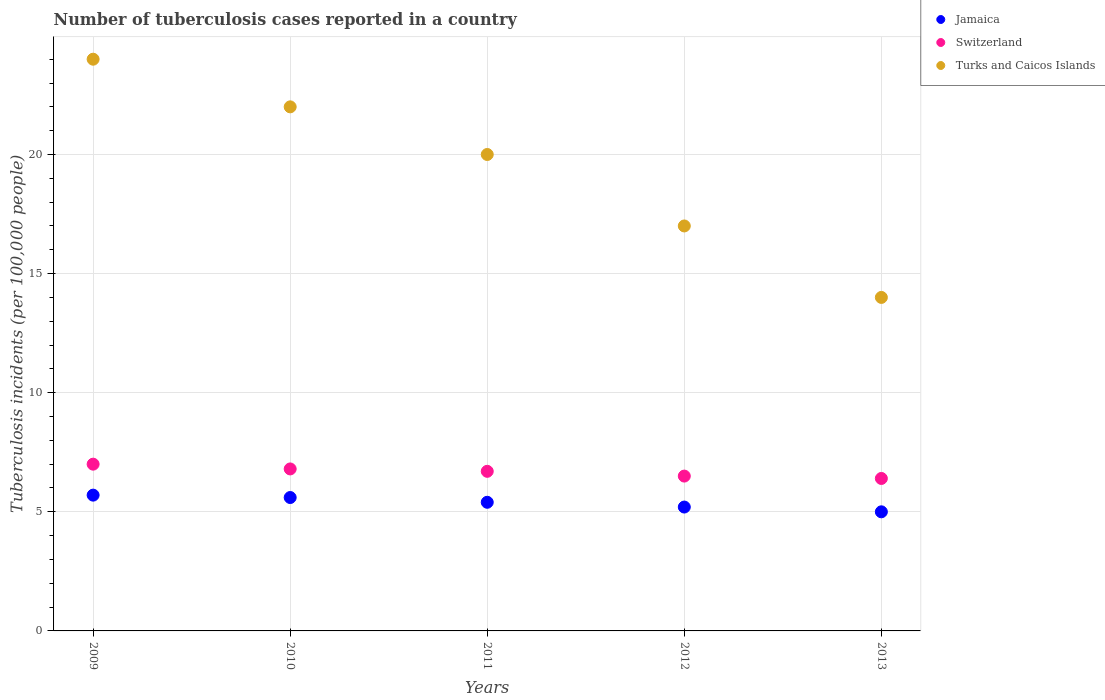What is the number of tuberculosis cases reported in in Turks and Caicos Islands in 2011?
Your answer should be compact. 20. Across all years, what is the maximum number of tuberculosis cases reported in in Turks and Caicos Islands?
Provide a short and direct response. 24. Across all years, what is the minimum number of tuberculosis cases reported in in Turks and Caicos Islands?
Keep it short and to the point. 14. In which year was the number of tuberculosis cases reported in in Jamaica maximum?
Ensure brevity in your answer.  2009. In which year was the number of tuberculosis cases reported in in Jamaica minimum?
Your answer should be compact. 2013. What is the total number of tuberculosis cases reported in in Turks and Caicos Islands in the graph?
Keep it short and to the point. 97. What is the difference between the number of tuberculosis cases reported in in Switzerland in 2012 and that in 2013?
Provide a succinct answer. 0.1. What is the average number of tuberculosis cases reported in in Switzerland per year?
Provide a succinct answer. 6.68. In the year 2013, what is the difference between the number of tuberculosis cases reported in in Jamaica and number of tuberculosis cases reported in in Turks and Caicos Islands?
Ensure brevity in your answer.  -9. In how many years, is the number of tuberculosis cases reported in in Turks and Caicos Islands greater than 15?
Make the answer very short. 4. Is the number of tuberculosis cases reported in in Switzerland in 2010 less than that in 2013?
Keep it short and to the point. No. Is the difference between the number of tuberculosis cases reported in in Jamaica in 2009 and 2011 greater than the difference between the number of tuberculosis cases reported in in Turks and Caicos Islands in 2009 and 2011?
Ensure brevity in your answer.  No. What is the difference between the highest and the second highest number of tuberculosis cases reported in in Switzerland?
Provide a succinct answer. 0.2. What is the difference between the highest and the lowest number of tuberculosis cases reported in in Jamaica?
Your answer should be compact. 0.7. In how many years, is the number of tuberculosis cases reported in in Switzerland greater than the average number of tuberculosis cases reported in in Switzerland taken over all years?
Provide a short and direct response. 3. Is the number of tuberculosis cases reported in in Switzerland strictly greater than the number of tuberculosis cases reported in in Turks and Caicos Islands over the years?
Your response must be concise. No. Is the number of tuberculosis cases reported in in Turks and Caicos Islands strictly less than the number of tuberculosis cases reported in in Switzerland over the years?
Offer a very short reply. No. How many dotlines are there?
Make the answer very short. 3. What is the difference between two consecutive major ticks on the Y-axis?
Offer a very short reply. 5. Are the values on the major ticks of Y-axis written in scientific E-notation?
Give a very brief answer. No. Does the graph contain any zero values?
Provide a succinct answer. No. How many legend labels are there?
Provide a succinct answer. 3. What is the title of the graph?
Offer a very short reply. Number of tuberculosis cases reported in a country. Does "Armenia" appear as one of the legend labels in the graph?
Your answer should be compact. No. What is the label or title of the Y-axis?
Offer a very short reply. Tuberculosis incidents (per 100,0 people). What is the Tuberculosis incidents (per 100,000 people) of Switzerland in 2009?
Offer a very short reply. 7. What is the Tuberculosis incidents (per 100,000 people) of Turks and Caicos Islands in 2009?
Offer a terse response. 24. What is the Tuberculosis incidents (per 100,000 people) in Turks and Caicos Islands in 2010?
Your answer should be very brief. 22. What is the Tuberculosis incidents (per 100,000 people) of Jamaica in 2011?
Your answer should be very brief. 5.4. What is the Tuberculosis incidents (per 100,000 people) of Switzerland in 2011?
Offer a very short reply. 6.7. What is the Tuberculosis incidents (per 100,000 people) of Turks and Caicos Islands in 2011?
Ensure brevity in your answer.  20. What is the Tuberculosis incidents (per 100,000 people) of Switzerland in 2012?
Your response must be concise. 6.5. What is the Tuberculosis incidents (per 100,000 people) in Jamaica in 2013?
Your answer should be very brief. 5. Across all years, what is the maximum Tuberculosis incidents (per 100,000 people) in Switzerland?
Make the answer very short. 7. Across all years, what is the maximum Tuberculosis incidents (per 100,000 people) of Turks and Caicos Islands?
Offer a very short reply. 24. What is the total Tuberculosis incidents (per 100,000 people) of Jamaica in the graph?
Your answer should be very brief. 26.9. What is the total Tuberculosis incidents (per 100,000 people) in Switzerland in the graph?
Ensure brevity in your answer.  33.4. What is the total Tuberculosis incidents (per 100,000 people) of Turks and Caicos Islands in the graph?
Your answer should be very brief. 97. What is the difference between the Tuberculosis incidents (per 100,000 people) in Jamaica in 2009 and that in 2010?
Give a very brief answer. 0.1. What is the difference between the Tuberculosis incidents (per 100,000 people) of Jamaica in 2009 and that in 2011?
Provide a succinct answer. 0.3. What is the difference between the Tuberculosis incidents (per 100,000 people) of Switzerland in 2009 and that in 2011?
Keep it short and to the point. 0.3. What is the difference between the Tuberculosis incidents (per 100,000 people) in Switzerland in 2009 and that in 2012?
Offer a terse response. 0.5. What is the difference between the Tuberculosis incidents (per 100,000 people) of Turks and Caicos Islands in 2009 and that in 2012?
Your answer should be very brief. 7. What is the difference between the Tuberculosis incidents (per 100,000 people) in Switzerland in 2009 and that in 2013?
Offer a very short reply. 0.6. What is the difference between the Tuberculosis incidents (per 100,000 people) of Switzerland in 2010 and that in 2011?
Provide a succinct answer. 0.1. What is the difference between the Tuberculosis incidents (per 100,000 people) of Turks and Caicos Islands in 2010 and that in 2011?
Provide a succinct answer. 2. What is the difference between the Tuberculosis incidents (per 100,000 people) in Jamaica in 2010 and that in 2012?
Provide a short and direct response. 0.4. What is the difference between the Tuberculosis incidents (per 100,000 people) of Switzerland in 2010 and that in 2013?
Your answer should be very brief. 0.4. What is the difference between the Tuberculosis incidents (per 100,000 people) in Switzerland in 2011 and that in 2012?
Give a very brief answer. 0.2. What is the difference between the Tuberculosis incidents (per 100,000 people) of Switzerland in 2011 and that in 2013?
Your answer should be compact. 0.3. What is the difference between the Tuberculosis incidents (per 100,000 people) in Turks and Caicos Islands in 2011 and that in 2013?
Offer a very short reply. 6. What is the difference between the Tuberculosis incidents (per 100,000 people) in Jamaica in 2012 and that in 2013?
Make the answer very short. 0.2. What is the difference between the Tuberculosis incidents (per 100,000 people) of Turks and Caicos Islands in 2012 and that in 2013?
Offer a terse response. 3. What is the difference between the Tuberculosis incidents (per 100,000 people) in Jamaica in 2009 and the Tuberculosis incidents (per 100,000 people) in Switzerland in 2010?
Your answer should be compact. -1.1. What is the difference between the Tuberculosis incidents (per 100,000 people) of Jamaica in 2009 and the Tuberculosis incidents (per 100,000 people) of Turks and Caicos Islands in 2010?
Your answer should be compact. -16.3. What is the difference between the Tuberculosis incidents (per 100,000 people) in Jamaica in 2009 and the Tuberculosis incidents (per 100,000 people) in Switzerland in 2011?
Offer a terse response. -1. What is the difference between the Tuberculosis incidents (per 100,000 people) in Jamaica in 2009 and the Tuberculosis incidents (per 100,000 people) in Turks and Caicos Islands in 2011?
Your response must be concise. -14.3. What is the difference between the Tuberculosis incidents (per 100,000 people) of Jamaica in 2009 and the Tuberculosis incidents (per 100,000 people) of Turks and Caicos Islands in 2012?
Provide a short and direct response. -11.3. What is the difference between the Tuberculosis incidents (per 100,000 people) of Jamaica in 2009 and the Tuberculosis incidents (per 100,000 people) of Switzerland in 2013?
Offer a terse response. -0.7. What is the difference between the Tuberculosis incidents (per 100,000 people) in Jamaica in 2010 and the Tuberculosis incidents (per 100,000 people) in Turks and Caicos Islands in 2011?
Your answer should be very brief. -14.4. What is the difference between the Tuberculosis incidents (per 100,000 people) of Switzerland in 2010 and the Tuberculosis incidents (per 100,000 people) of Turks and Caicos Islands in 2011?
Offer a terse response. -13.2. What is the difference between the Tuberculosis incidents (per 100,000 people) in Jamaica in 2010 and the Tuberculosis incidents (per 100,000 people) in Turks and Caicos Islands in 2012?
Offer a very short reply. -11.4. What is the difference between the Tuberculosis incidents (per 100,000 people) in Jamaica in 2010 and the Tuberculosis incidents (per 100,000 people) in Switzerland in 2013?
Offer a terse response. -0.8. What is the difference between the Tuberculosis incidents (per 100,000 people) of Jamaica in 2011 and the Tuberculosis incidents (per 100,000 people) of Turks and Caicos Islands in 2012?
Offer a very short reply. -11.6. What is the difference between the Tuberculosis incidents (per 100,000 people) of Switzerland in 2011 and the Tuberculosis incidents (per 100,000 people) of Turks and Caicos Islands in 2012?
Ensure brevity in your answer.  -10.3. What is the difference between the Tuberculosis incidents (per 100,000 people) in Jamaica in 2011 and the Tuberculosis incidents (per 100,000 people) in Turks and Caicos Islands in 2013?
Keep it short and to the point. -8.6. What is the difference between the Tuberculosis incidents (per 100,000 people) of Jamaica in 2012 and the Tuberculosis incidents (per 100,000 people) of Turks and Caicos Islands in 2013?
Provide a succinct answer. -8.8. What is the difference between the Tuberculosis incidents (per 100,000 people) of Switzerland in 2012 and the Tuberculosis incidents (per 100,000 people) of Turks and Caicos Islands in 2013?
Offer a very short reply. -7.5. What is the average Tuberculosis incidents (per 100,000 people) in Jamaica per year?
Give a very brief answer. 5.38. What is the average Tuberculosis incidents (per 100,000 people) in Switzerland per year?
Offer a terse response. 6.68. In the year 2009, what is the difference between the Tuberculosis incidents (per 100,000 people) of Jamaica and Tuberculosis incidents (per 100,000 people) of Switzerland?
Keep it short and to the point. -1.3. In the year 2009, what is the difference between the Tuberculosis incidents (per 100,000 people) of Jamaica and Tuberculosis incidents (per 100,000 people) of Turks and Caicos Islands?
Your answer should be very brief. -18.3. In the year 2009, what is the difference between the Tuberculosis incidents (per 100,000 people) of Switzerland and Tuberculosis incidents (per 100,000 people) of Turks and Caicos Islands?
Offer a very short reply. -17. In the year 2010, what is the difference between the Tuberculosis incidents (per 100,000 people) in Jamaica and Tuberculosis incidents (per 100,000 people) in Turks and Caicos Islands?
Your response must be concise. -16.4. In the year 2010, what is the difference between the Tuberculosis incidents (per 100,000 people) in Switzerland and Tuberculosis incidents (per 100,000 people) in Turks and Caicos Islands?
Offer a terse response. -15.2. In the year 2011, what is the difference between the Tuberculosis incidents (per 100,000 people) of Jamaica and Tuberculosis incidents (per 100,000 people) of Switzerland?
Provide a succinct answer. -1.3. In the year 2011, what is the difference between the Tuberculosis incidents (per 100,000 people) of Jamaica and Tuberculosis incidents (per 100,000 people) of Turks and Caicos Islands?
Keep it short and to the point. -14.6. In the year 2011, what is the difference between the Tuberculosis incidents (per 100,000 people) in Switzerland and Tuberculosis incidents (per 100,000 people) in Turks and Caicos Islands?
Provide a short and direct response. -13.3. In the year 2012, what is the difference between the Tuberculosis incidents (per 100,000 people) of Jamaica and Tuberculosis incidents (per 100,000 people) of Turks and Caicos Islands?
Ensure brevity in your answer.  -11.8. In the year 2012, what is the difference between the Tuberculosis incidents (per 100,000 people) of Switzerland and Tuberculosis incidents (per 100,000 people) of Turks and Caicos Islands?
Offer a very short reply. -10.5. In the year 2013, what is the difference between the Tuberculosis incidents (per 100,000 people) in Jamaica and Tuberculosis incidents (per 100,000 people) in Switzerland?
Provide a short and direct response. -1.4. In the year 2013, what is the difference between the Tuberculosis incidents (per 100,000 people) in Switzerland and Tuberculosis incidents (per 100,000 people) in Turks and Caicos Islands?
Keep it short and to the point. -7.6. What is the ratio of the Tuberculosis incidents (per 100,000 people) in Jamaica in 2009 to that in 2010?
Make the answer very short. 1.02. What is the ratio of the Tuberculosis incidents (per 100,000 people) in Switzerland in 2009 to that in 2010?
Your answer should be compact. 1.03. What is the ratio of the Tuberculosis incidents (per 100,000 people) in Turks and Caicos Islands in 2009 to that in 2010?
Your answer should be compact. 1.09. What is the ratio of the Tuberculosis incidents (per 100,000 people) of Jamaica in 2009 to that in 2011?
Offer a terse response. 1.06. What is the ratio of the Tuberculosis incidents (per 100,000 people) in Switzerland in 2009 to that in 2011?
Your answer should be compact. 1.04. What is the ratio of the Tuberculosis incidents (per 100,000 people) of Jamaica in 2009 to that in 2012?
Offer a terse response. 1.1. What is the ratio of the Tuberculosis incidents (per 100,000 people) in Switzerland in 2009 to that in 2012?
Your answer should be very brief. 1.08. What is the ratio of the Tuberculosis incidents (per 100,000 people) in Turks and Caicos Islands in 2009 to that in 2012?
Your answer should be compact. 1.41. What is the ratio of the Tuberculosis incidents (per 100,000 people) of Jamaica in 2009 to that in 2013?
Keep it short and to the point. 1.14. What is the ratio of the Tuberculosis incidents (per 100,000 people) of Switzerland in 2009 to that in 2013?
Your answer should be compact. 1.09. What is the ratio of the Tuberculosis incidents (per 100,000 people) in Turks and Caicos Islands in 2009 to that in 2013?
Keep it short and to the point. 1.71. What is the ratio of the Tuberculosis incidents (per 100,000 people) in Switzerland in 2010 to that in 2011?
Provide a short and direct response. 1.01. What is the ratio of the Tuberculosis incidents (per 100,000 people) of Turks and Caicos Islands in 2010 to that in 2011?
Provide a succinct answer. 1.1. What is the ratio of the Tuberculosis incidents (per 100,000 people) of Jamaica in 2010 to that in 2012?
Provide a succinct answer. 1.08. What is the ratio of the Tuberculosis incidents (per 100,000 people) of Switzerland in 2010 to that in 2012?
Give a very brief answer. 1.05. What is the ratio of the Tuberculosis incidents (per 100,000 people) of Turks and Caicos Islands in 2010 to that in 2012?
Offer a very short reply. 1.29. What is the ratio of the Tuberculosis incidents (per 100,000 people) in Jamaica in 2010 to that in 2013?
Your response must be concise. 1.12. What is the ratio of the Tuberculosis incidents (per 100,000 people) in Turks and Caicos Islands in 2010 to that in 2013?
Keep it short and to the point. 1.57. What is the ratio of the Tuberculosis incidents (per 100,000 people) of Switzerland in 2011 to that in 2012?
Provide a succinct answer. 1.03. What is the ratio of the Tuberculosis incidents (per 100,000 people) of Turks and Caicos Islands in 2011 to that in 2012?
Ensure brevity in your answer.  1.18. What is the ratio of the Tuberculosis incidents (per 100,000 people) of Jamaica in 2011 to that in 2013?
Make the answer very short. 1.08. What is the ratio of the Tuberculosis incidents (per 100,000 people) of Switzerland in 2011 to that in 2013?
Your answer should be very brief. 1.05. What is the ratio of the Tuberculosis incidents (per 100,000 people) of Turks and Caicos Islands in 2011 to that in 2013?
Ensure brevity in your answer.  1.43. What is the ratio of the Tuberculosis incidents (per 100,000 people) in Switzerland in 2012 to that in 2013?
Provide a succinct answer. 1.02. What is the ratio of the Tuberculosis incidents (per 100,000 people) of Turks and Caicos Islands in 2012 to that in 2013?
Make the answer very short. 1.21. What is the difference between the highest and the second highest Tuberculosis incidents (per 100,000 people) of Turks and Caicos Islands?
Provide a succinct answer. 2. What is the difference between the highest and the lowest Tuberculosis incidents (per 100,000 people) of Switzerland?
Your answer should be compact. 0.6. What is the difference between the highest and the lowest Tuberculosis incidents (per 100,000 people) in Turks and Caicos Islands?
Offer a very short reply. 10. 